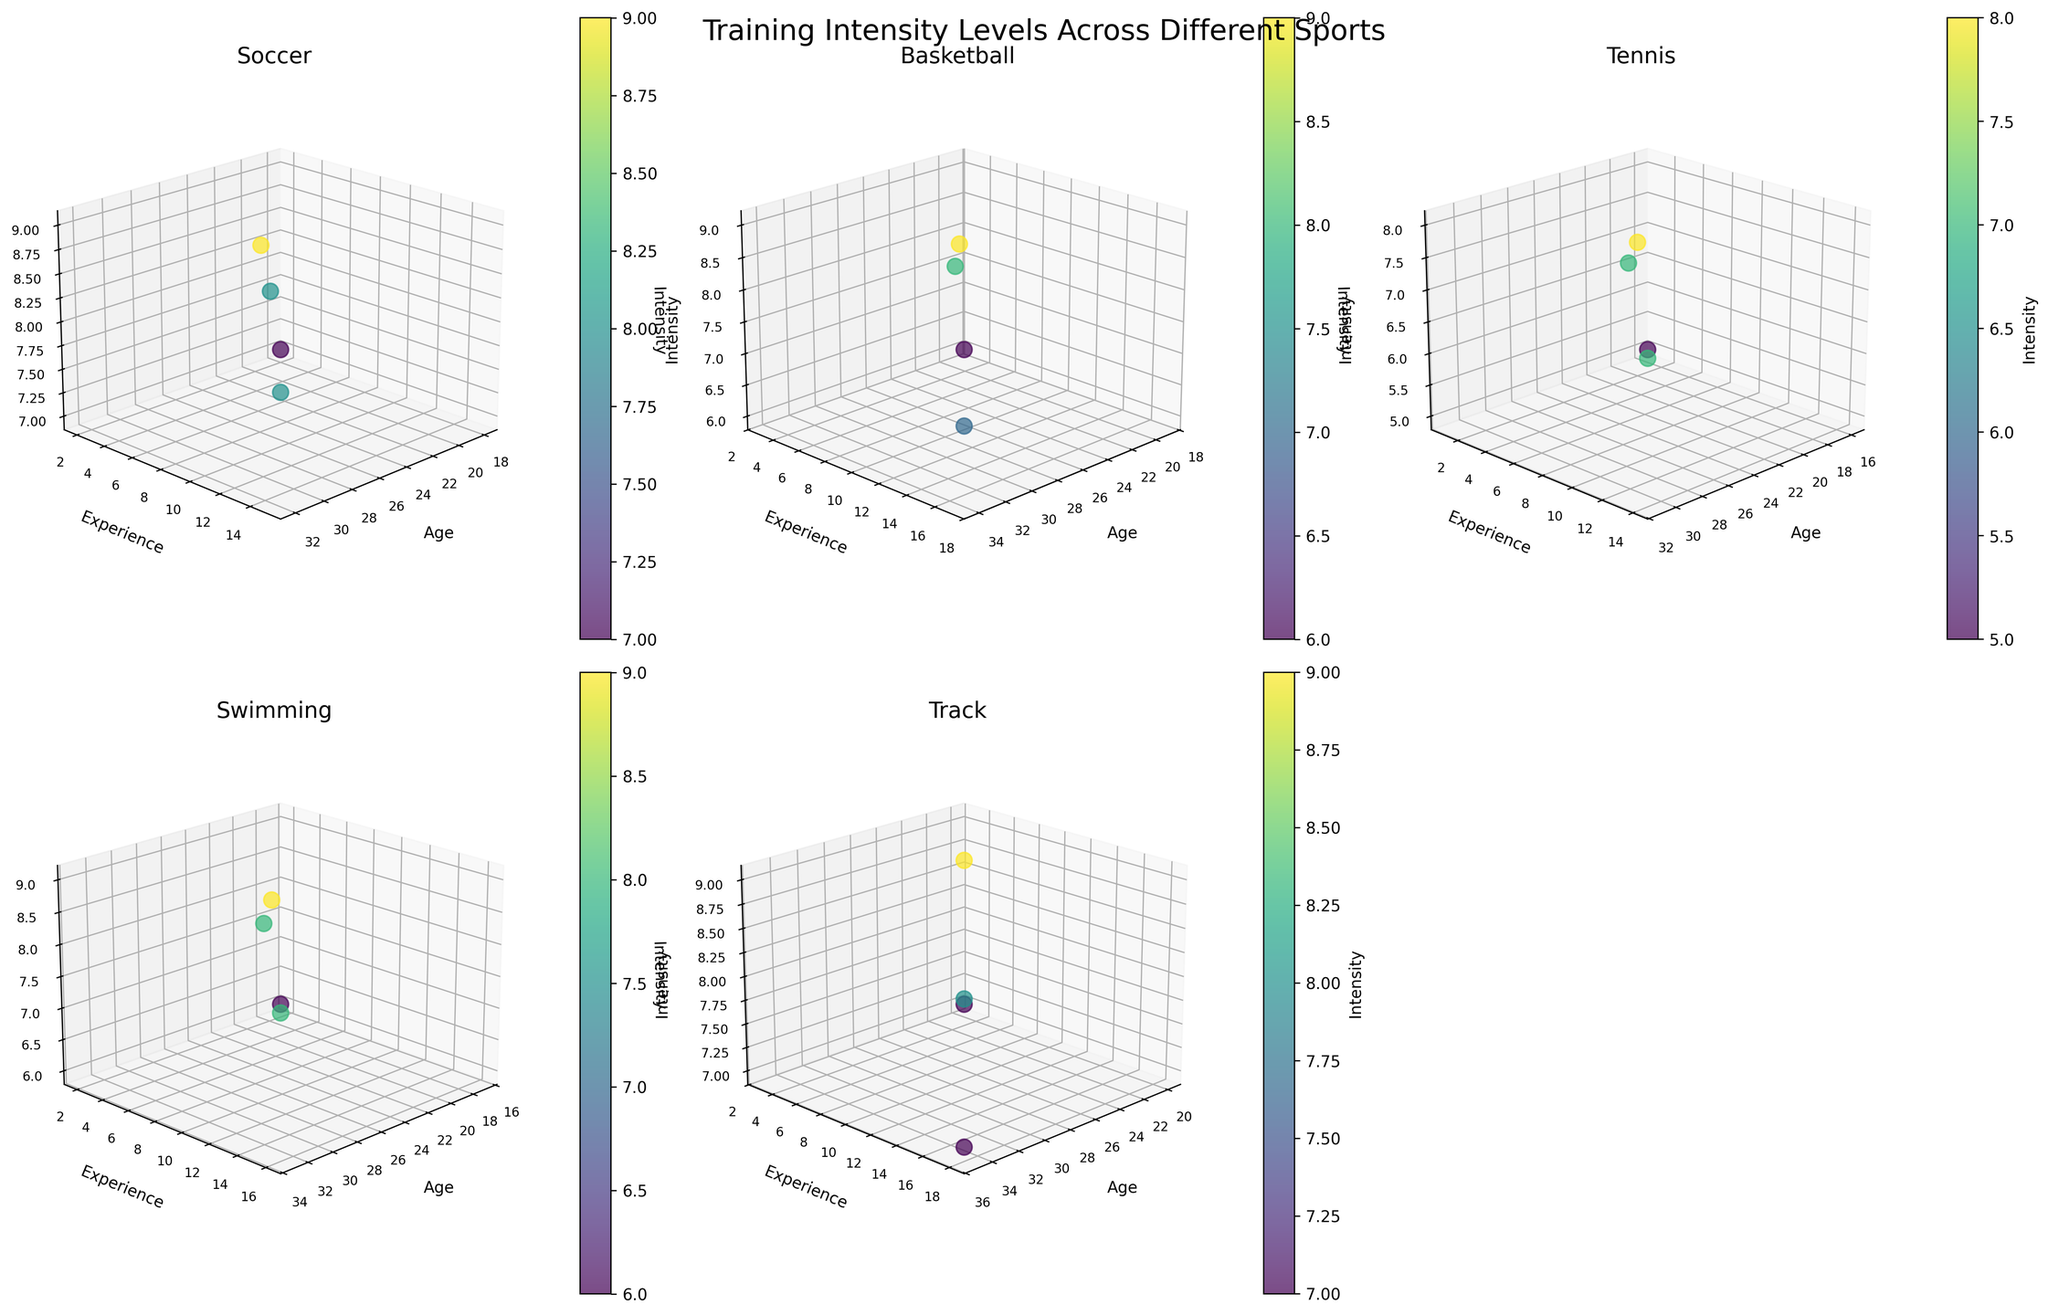What is the title of the overall plot? Look at the large text title centered above all subplots.
Answer: Training Intensity Levels Across Different Sports Which axis represents "Intensity" in the subplots? Identify the axis labeled as "Intensity." It is the z-axis in each subplot.
Answer: z-axis How many different sports are displayed in the figure? Count the number of subplots, each representing a different sport.
Answer: 5 What is the range of ages for Soccer players displayed in the plot? Check the x-axis values in the Soccer subplot to determine the minimum and maximum ages.
Answer: 18 to 32 Which sport shows the highest training intensity level among the athletes? Look at the color bar on the right and identify the sport with the highest color intensity in the subplots. The highest intensity corresponds to a value of 9.
Answer: Basketball, Soccer, Swimming, Track Compare the training intensity of a 28-year-old Soccer player with a 28-year-old Basketball player. Examine both the Soccer and Basketball subplots for data points at age 28 and compare their z-values (Intensity).
Answer: Soccer: 9, Basketball: 9 What is the average training intensity for Tennis players? Identify the Intensity values for Tennis players, sum these values, and divide by the number of data points. The Intensities are 5, 7, 8, and 7.
Answer: (5 + 7 + 8 + 7) / 4 = 6.75 Which sport has the widest range of experience levels among athletes? Compare the range of the y-axis (Experience) in each subplot and identify the sport with the largest difference between the minimum and maximum values.
Answer: Track (1 to 18) What is the average training intensity for athletes older than 30 across all sports? Filter for athletes aged 31, 32, 33, 34, 35, look up their Intensity, and calculate the average. The Intensities are: 8, 7, 8, 7, 7.
Answer: (8 + 7 + 8 + 7 + 7) / 5 = 7.4 